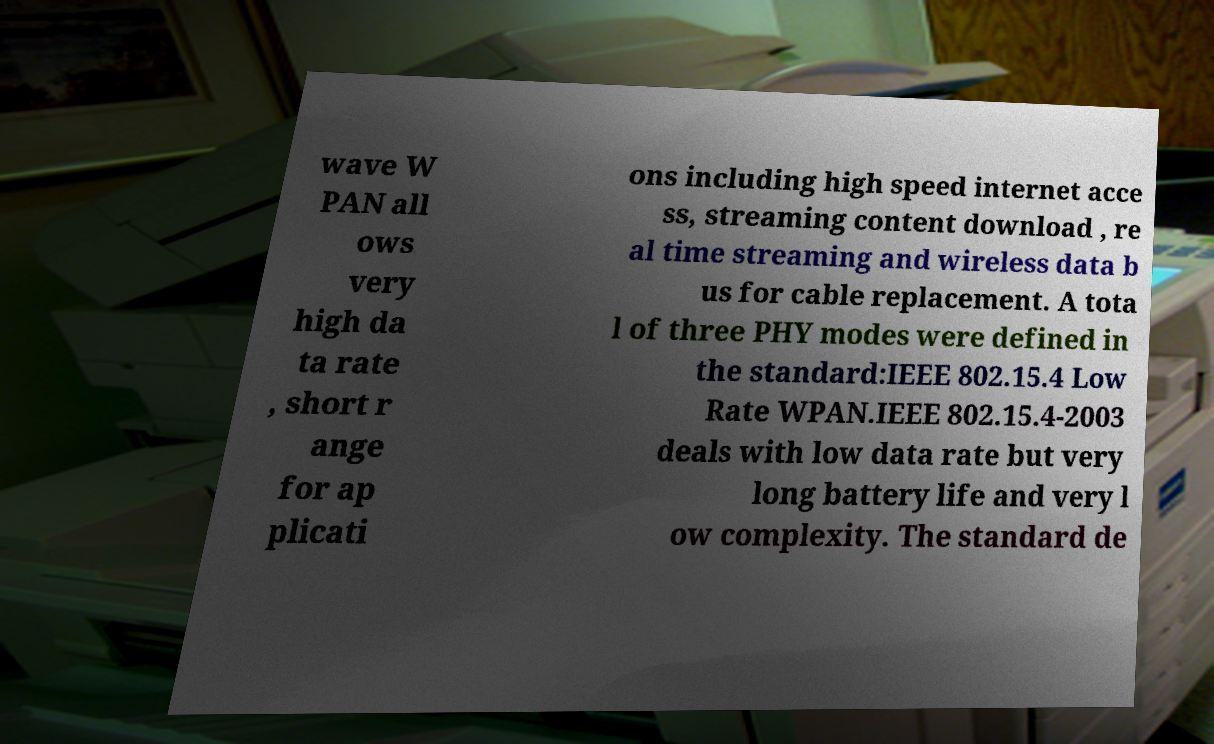For documentation purposes, I need the text within this image transcribed. Could you provide that? wave W PAN all ows very high da ta rate , short r ange for ap plicati ons including high speed internet acce ss, streaming content download , re al time streaming and wireless data b us for cable replacement. A tota l of three PHY modes were defined in the standard:IEEE 802.15.4 Low Rate WPAN.IEEE 802.15.4-2003 deals with low data rate but very long battery life and very l ow complexity. The standard de 